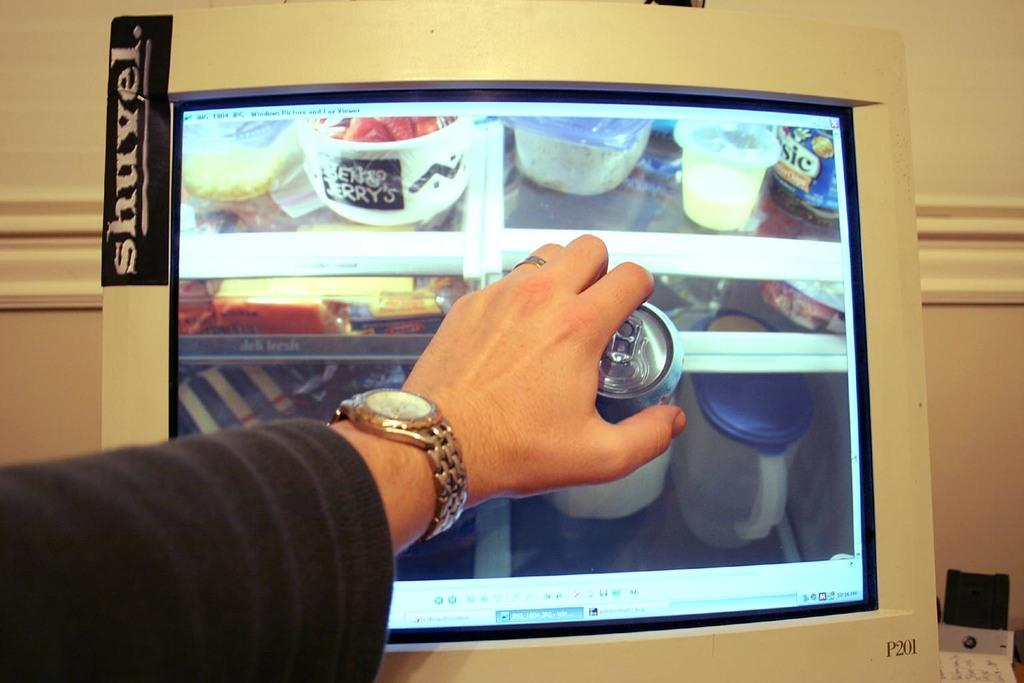Provide a one-sentence caption for the provided image. A computer monitor that has a sticker that says shuvel on it. 